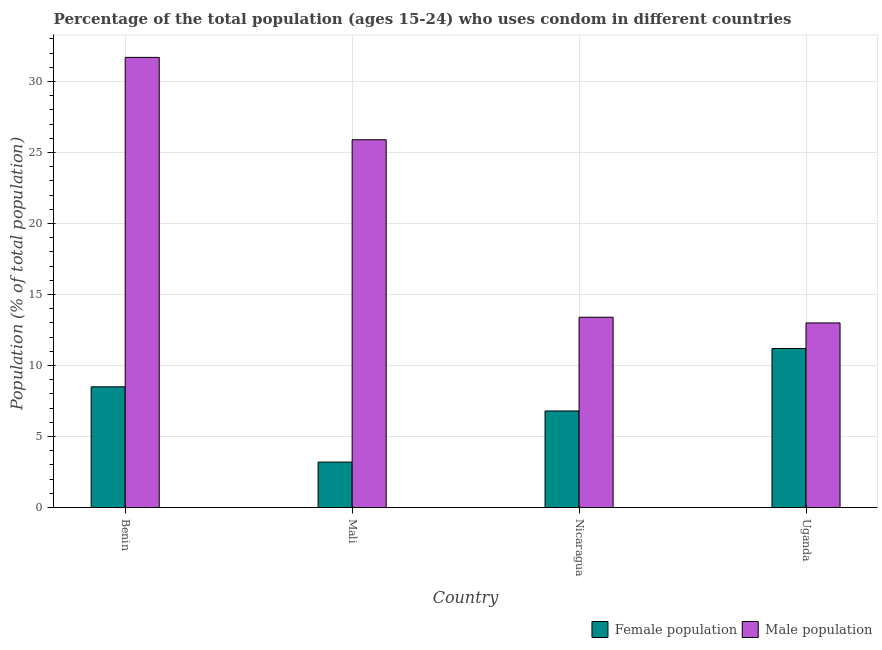How many different coloured bars are there?
Give a very brief answer. 2. What is the label of the 1st group of bars from the left?
Offer a very short reply. Benin. Across all countries, what is the maximum male population?
Provide a short and direct response. 31.7. In which country was the female population maximum?
Your response must be concise. Uganda. In which country was the female population minimum?
Provide a short and direct response. Mali. What is the total male population in the graph?
Provide a succinct answer. 84. What is the difference between the female population in Mali and that in Nicaragua?
Give a very brief answer. -3.6. What is the difference between the male population in Uganda and the female population in Mali?
Make the answer very short. 9.8. What is the average male population per country?
Provide a short and direct response. 21. What is the difference between the female population and male population in Benin?
Make the answer very short. -23.2. In how many countries, is the female population greater than 21 %?
Provide a short and direct response. 0. What is the ratio of the male population in Benin to that in Nicaragua?
Give a very brief answer. 2.37. What is the difference between the highest and the second highest female population?
Ensure brevity in your answer.  2.7. In how many countries, is the male population greater than the average male population taken over all countries?
Your answer should be very brief. 2. Is the sum of the female population in Mali and Uganda greater than the maximum male population across all countries?
Offer a terse response. No. What does the 1st bar from the left in Benin represents?
Provide a short and direct response. Female population. What does the 2nd bar from the right in Benin represents?
Keep it short and to the point. Female population. How many bars are there?
Your answer should be compact. 8. Are all the bars in the graph horizontal?
Offer a very short reply. No. Are the values on the major ticks of Y-axis written in scientific E-notation?
Provide a succinct answer. No. Does the graph contain any zero values?
Provide a short and direct response. No. What is the title of the graph?
Your answer should be very brief. Percentage of the total population (ages 15-24) who uses condom in different countries. What is the label or title of the X-axis?
Your answer should be very brief. Country. What is the label or title of the Y-axis?
Make the answer very short. Population (% of total population) . What is the Population (% of total population)  of Female population in Benin?
Your response must be concise. 8.5. What is the Population (% of total population)  of Male population in Benin?
Your answer should be very brief. 31.7. What is the Population (% of total population)  in Male population in Mali?
Your answer should be compact. 25.9. What is the Population (% of total population)  in Male population in Nicaragua?
Keep it short and to the point. 13.4. Across all countries, what is the maximum Population (% of total population)  of Male population?
Make the answer very short. 31.7. Across all countries, what is the minimum Population (% of total population)  in Female population?
Ensure brevity in your answer.  3.2. Across all countries, what is the minimum Population (% of total population)  in Male population?
Make the answer very short. 13. What is the total Population (% of total population)  in Female population in the graph?
Offer a very short reply. 29.7. What is the total Population (% of total population)  in Male population in the graph?
Give a very brief answer. 84. What is the difference between the Population (% of total population)  of Female population in Benin and that in Mali?
Offer a very short reply. 5.3. What is the difference between the Population (% of total population)  in Male population in Benin and that in Mali?
Keep it short and to the point. 5.8. What is the difference between the Population (% of total population)  of Female population in Benin and that in Nicaragua?
Provide a succinct answer. 1.7. What is the difference between the Population (% of total population)  in Male population in Benin and that in Nicaragua?
Offer a terse response. 18.3. What is the difference between the Population (% of total population)  in Female population in Benin and that in Uganda?
Ensure brevity in your answer.  -2.7. What is the difference between the Population (% of total population)  of Male population in Benin and that in Uganda?
Keep it short and to the point. 18.7. What is the difference between the Population (% of total population)  in Male population in Mali and that in Nicaragua?
Provide a succinct answer. 12.5. What is the difference between the Population (% of total population)  of Female population in Mali and that in Uganda?
Give a very brief answer. -8. What is the difference between the Population (% of total population)  of Male population in Mali and that in Uganda?
Provide a short and direct response. 12.9. What is the difference between the Population (% of total population)  of Female population in Nicaragua and that in Uganda?
Make the answer very short. -4.4. What is the difference between the Population (% of total population)  in Male population in Nicaragua and that in Uganda?
Your answer should be compact. 0.4. What is the difference between the Population (% of total population)  in Female population in Benin and the Population (% of total population)  in Male population in Mali?
Your answer should be very brief. -17.4. What is the difference between the Population (% of total population)  of Female population in Benin and the Population (% of total population)  of Male population in Nicaragua?
Provide a short and direct response. -4.9. What is the difference between the Population (% of total population)  of Female population in Benin and the Population (% of total population)  of Male population in Uganda?
Give a very brief answer. -4.5. What is the difference between the Population (% of total population)  of Female population in Mali and the Population (% of total population)  of Male population in Nicaragua?
Give a very brief answer. -10.2. What is the difference between the Population (% of total population)  in Female population in Mali and the Population (% of total population)  in Male population in Uganda?
Your response must be concise. -9.8. What is the difference between the Population (% of total population)  in Female population in Nicaragua and the Population (% of total population)  in Male population in Uganda?
Your answer should be very brief. -6.2. What is the average Population (% of total population)  of Female population per country?
Your answer should be very brief. 7.42. What is the difference between the Population (% of total population)  of Female population and Population (% of total population)  of Male population in Benin?
Your answer should be very brief. -23.2. What is the difference between the Population (% of total population)  in Female population and Population (% of total population)  in Male population in Mali?
Keep it short and to the point. -22.7. What is the difference between the Population (% of total population)  in Female population and Population (% of total population)  in Male population in Nicaragua?
Give a very brief answer. -6.6. What is the ratio of the Population (% of total population)  of Female population in Benin to that in Mali?
Provide a succinct answer. 2.66. What is the ratio of the Population (% of total population)  of Male population in Benin to that in Mali?
Your answer should be compact. 1.22. What is the ratio of the Population (% of total population)  in Female population in Benin to that in Nicaragua?
Ensure brevity in your answer.  1.25. What is the ratio of the Population (% of total population)  in Male population in Benin to that in Nicaragua?
Offer a very short reply. 2.37. What is the ratio of the Population (% of total population)  of Female population in Benin to that in Uganda?
Ensure brevity in your answer.  0.76. What is the ratio of the Population (% of total population)  of Male population in Benin to that in Uganda?
Your answer should be very brief. 2.44. What is the ratio of the Population (% of total population)  in Female population in Mali to that in Nicaragua?
Provide a short and direct response. 0.47. What is the ratio of the Population (% of total population)  in Male population in Mali to that in Nicaragua?
Your answer should be compact. 1.93. What is the ratio of the Population (% of total population)  of Female population in Mali to that in Uganda?
Make the answer very short. 0.29. What is the ratio of the Population (% of total population)  in Male population in Mali to that in Uganda?
Offer a very short reply. 1.99. What is the ratio of the Population (% of total population)  of Female population in Nicaragua to that in Uganda?
Your answer should be very brief. 0.61. What is the ratio of the Population (% of total population)  in Male population in Nicaragua to that in Uganda?
Your answer should be compact. 1.03. What is the difference between the highest and the lowest Population (% of total population)  in Female population?
Keep it short and to the point. 8. 